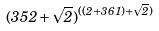<formula> <loc_0><loc_0><loc_500><loc_500>( 3 5 2 + \sqrt { 2 } ) ^ { ( ( 2 + 3 6 1 ) + \sqrt { 2 } ) }</formula> 